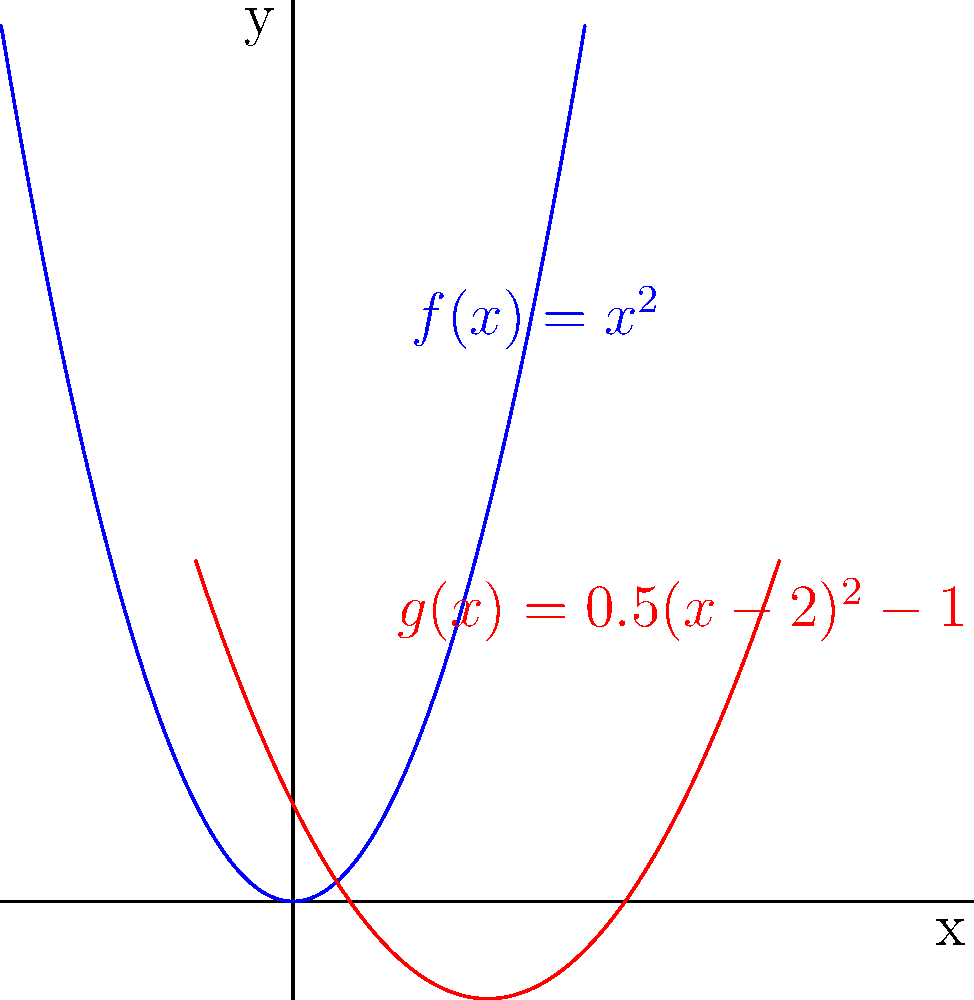Consider the parabola $f(x)=x^2$ (shown in blue) and its transformation $g(x)=0.5(x-2)^2-1$ (shown in red). Describe the sequence of transformations applied to $f(x)$ to obtain $g(x)$, and explain how each transformation affects the graph. To transform $f(x)=x^2$ into $g(x)=0.5(x-2)^2-1$, we apply the following sequence of transformations:

1. Vertical stretch/compression:
   The factor 0.5 outside the parentheses indicates a vertical compression by a factor of 0.5.
   This makes the parabola appear "flatter" or "wider".

2. Horizontal translation:
   The term $(x-2)$ inside the parentheses represents a horizontal translation 2 units to the right.
   This moves the vertex of the parabola from (0,0) to (2,0).

3. Vertical translation:
   The -1 at the end represents a vertical translation 1 unit downward.
   This moves the vertex from (2,0) to (2,-1).

The order of these transformations is important:
- First, we apply the vertical stretch/compression.
- Then, we apply the horizontal translation.
- Finally, we apply the vertical translation.

This sequence ensures that the final parabola has its vertex at (2,-1) and is "flatter" than the original.
Answer: Vertical compression by 0.5, right shift by 2, down shift by 1. 